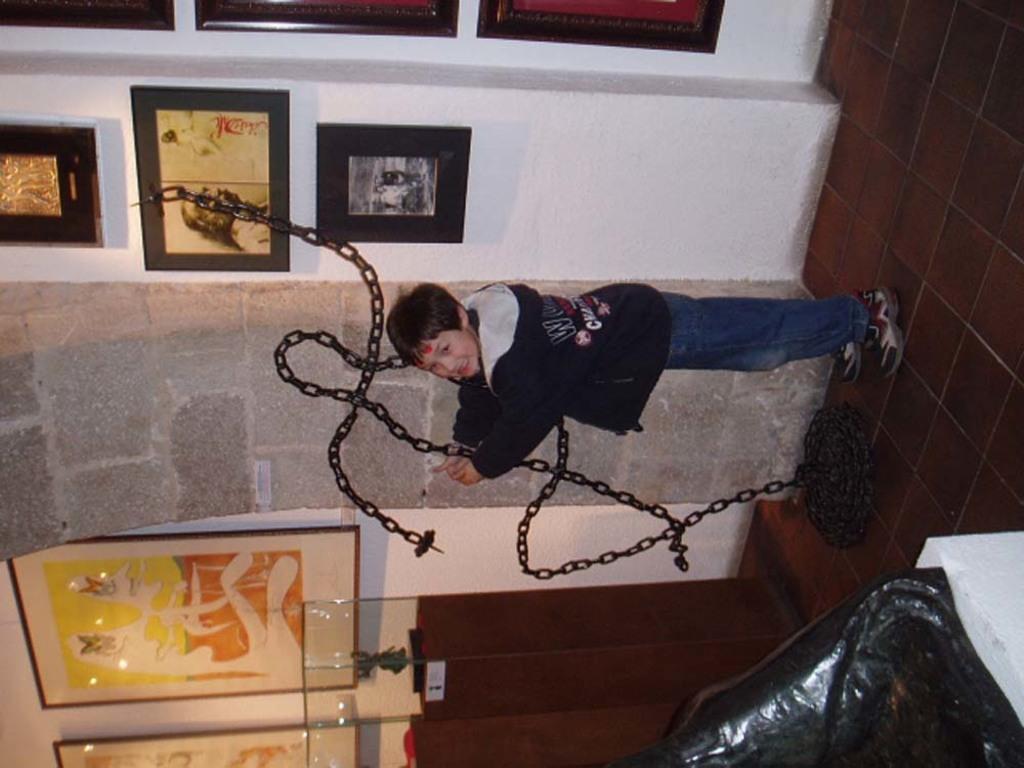Please provide a concise description of this image. In this picture there is a boy wearing black hoodie and jeans standing in the front and holding the chain in the hand. Behind there is a granite pillar and white wall on both the side with beautiful hanging photo frames. 